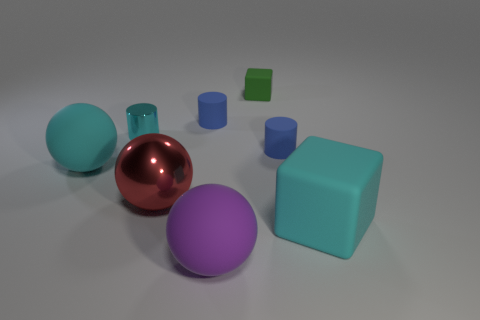What shape is the big cyan thing that is to the right of the big red thing?
Give a very brief answer. Cube. What size is the green object that is made of the same material as the cyan cube?
Provide a succinct answer. Small. How many big blue objects are the same shape as the large purple thing?
Provide a succinct answer. 0. Is the color of the rubber cylinder to the left of the purple thing the same as the small shiny thing?
Make the answer very short. No. What number of small blue cylinders are left of the big thing in front of the large object that is on the right side of the purple matte thing?
Your response must be concise. 1. What number of rubber objects are both to the right of the tiny green cube and in front of the red metallic object?
Provide a short and direct response. 1. What is the shape of the big thing that is the same color as the big cube?
Provide a succinct answer. Sphere. Are there any other things that have the same material as the big block?
Your answer should be very brief. Yes. Is the material of the red ball the same as the purple object?
Offer a very short reply. No. There is a shiny thing that is in front of the big cyan object left of the tiny blue rubber cylinder that is in front of the tiny cyan object; what shape is it?
Give a very brief answer. Sphere. 